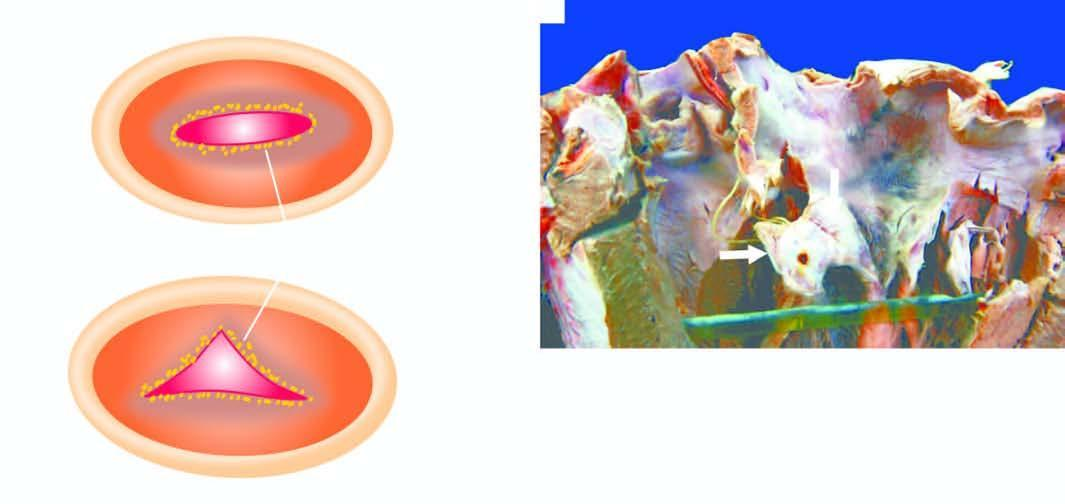what does the free surface and margin of the mitral valve show?
Answer the question using a single word or phrase. Tiny firm granular vegetations 